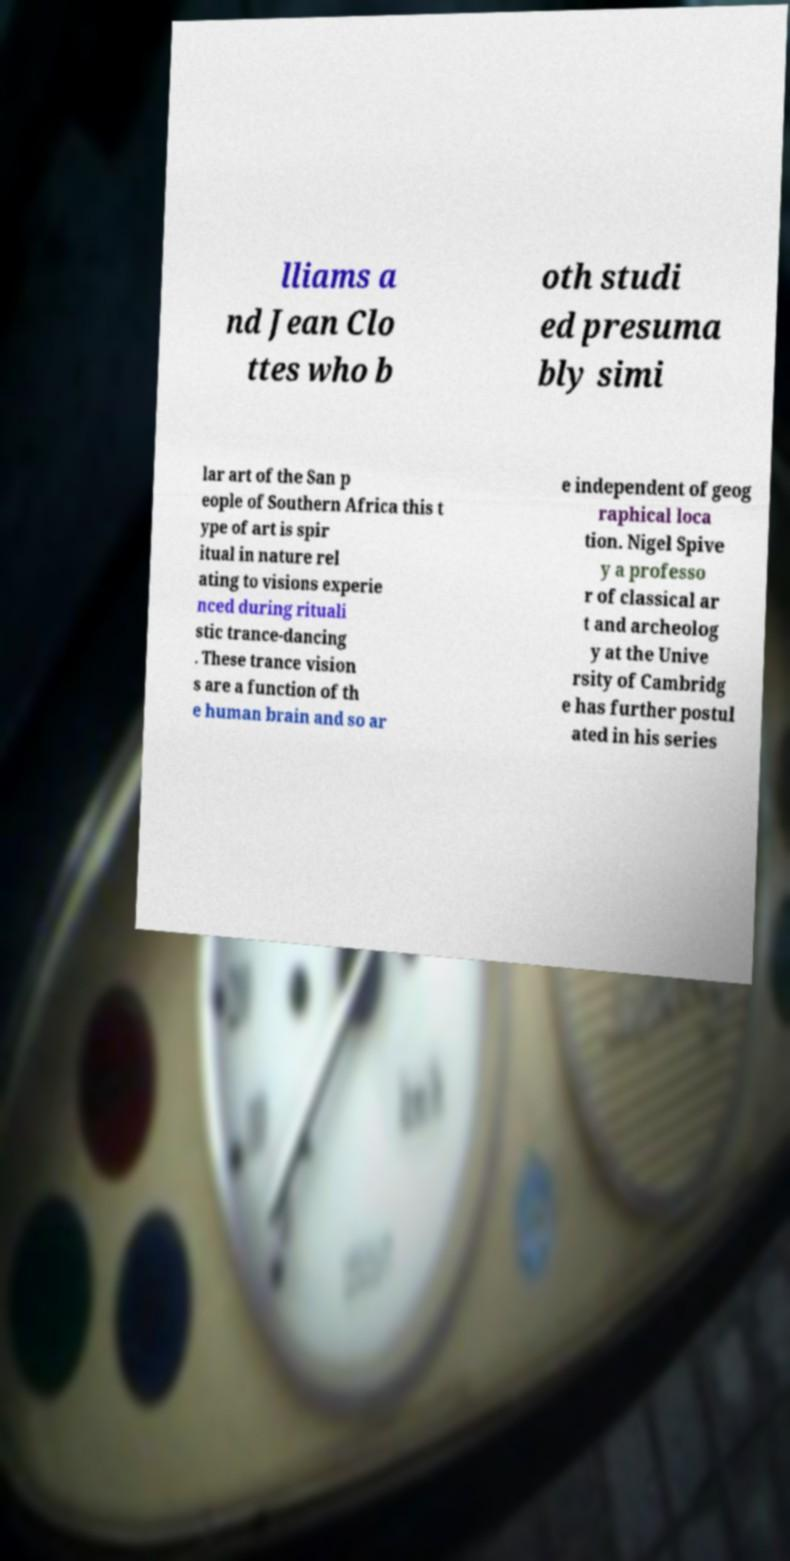Please read and relay the text visible in this image. What does it say? lliams a nd Jean Clo ttes who b oth studi ed presuma bly simi lar art of the San p eople of Southern Africa this t ype of art is spir itual in nature rel ating to visions experie nced during rituali stic trance-dancing . These trance vision s are a function of th e human brain and so ar e independent of geog raphical loca tion. Nigel Spive y a professo r of classical ar t and archeolog y at the Unive rsity of Cambridg e has further postul ated in his series 